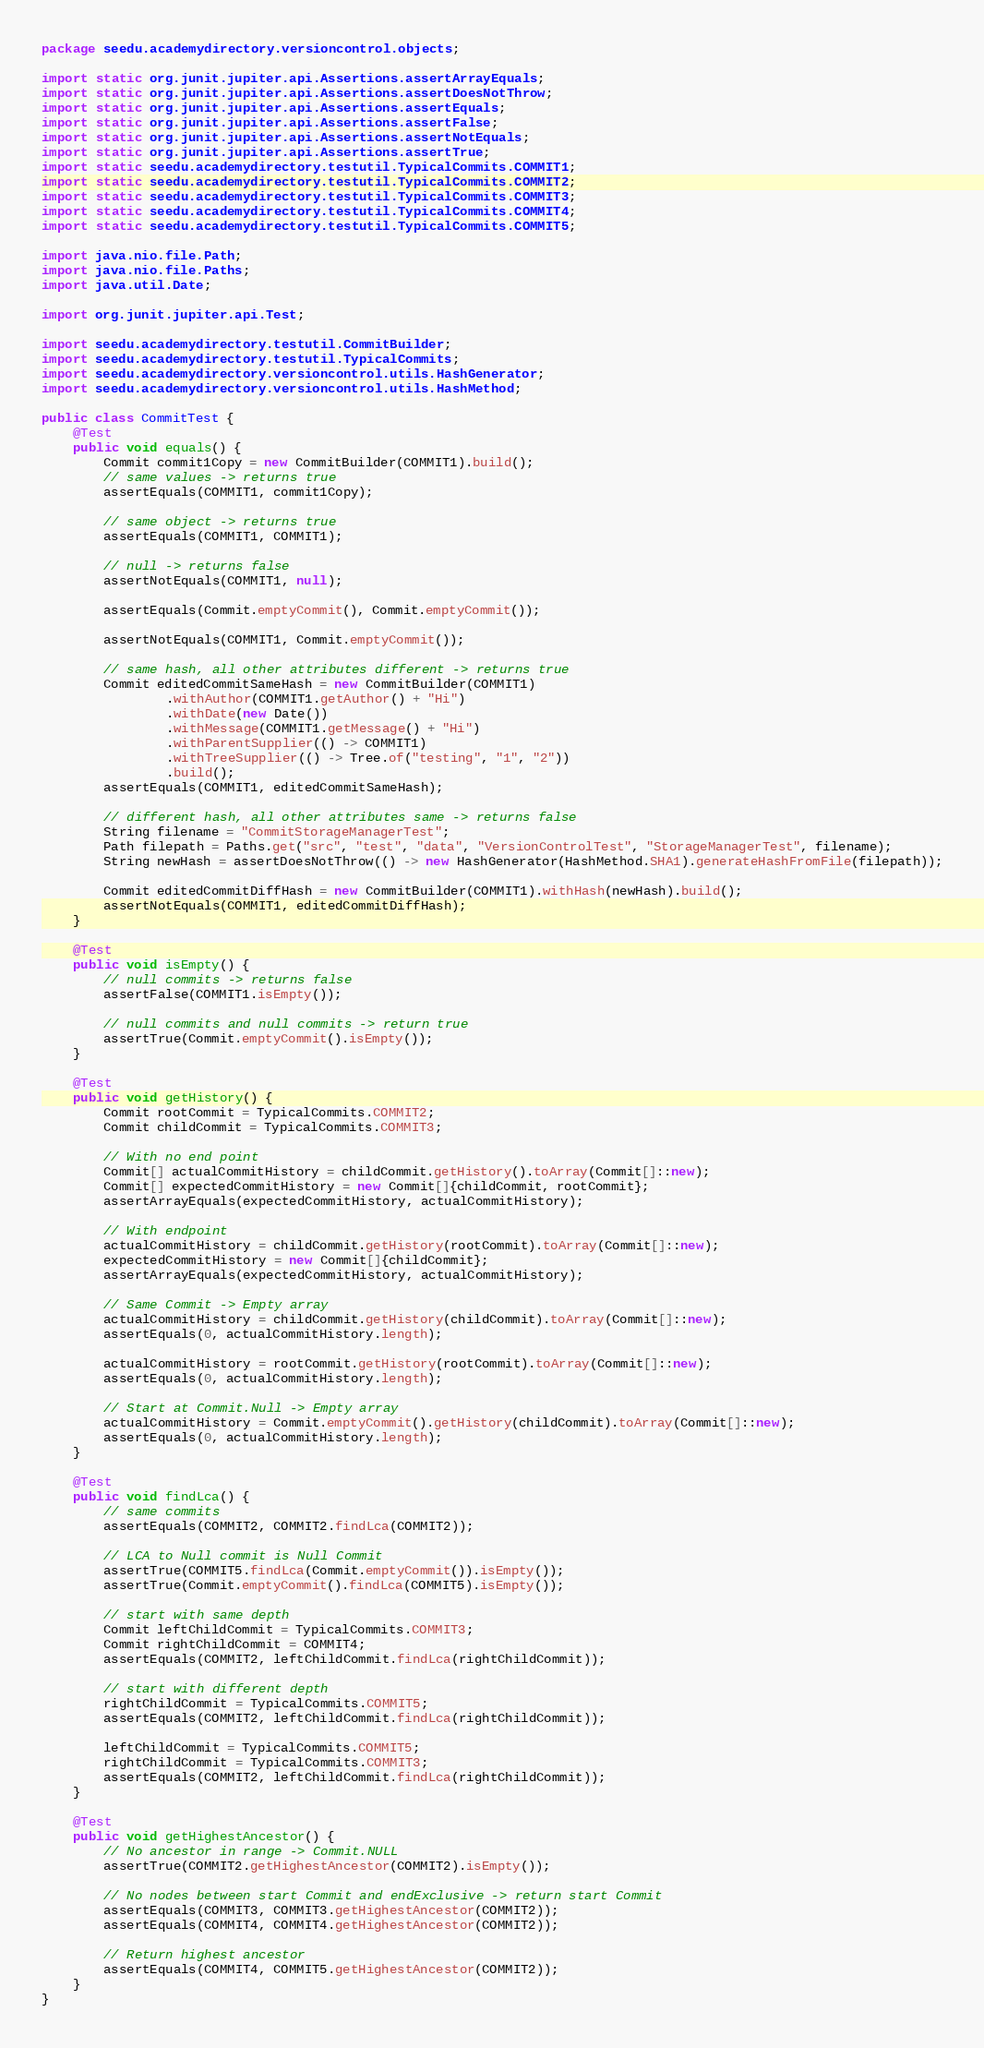<code> <loc_0><loc_0><loc_500><loc_500><_Java_>package seedu.academydirectory.versioncontrol.objects;

import static org.junit.jupiter.api.Assertions.assertArrayEquals;
import static org.junit.jupiter.api.Assertions.assertDoesNotThrow;
import static org.junit.jupiter.api.Assertions.assertEquals;
import static org.junit.jupiter.api.Assertions.assertFalse;
import static org.junit.jupiter.api.Assertions.assertNotEquals;
import static org.junit.jupiter.api.Assertions.assertTrue;
import static seedu.academydirectory.testutil.TypicalCommits.COMMIT1;
import static seedu.academydirectory.testutil.TypicalCommits.COMMIT2;
import static seedu.academydirectory.testutil.TypicalCommits.COMMIT3;
import static seedu.academydirectory.testutil.TypicalCommits.COMMIT4;
import static seedu.academydirectory.testutil.TypicalCommits.COMMIT5;

import java.nio.file.Path;
import java.nio.file.Paths;
import java.util.Date;

import org.junit.jupiter.api.Test;

import seedu.academydirectory.testutil.CommitBuilder;
import seedu.academydirectory.testutil.TypicalCommits;
import seedu.academydirectory.versioncontrol.utils.HashGenerator;
import seedu.academydirectory.versioncontrol.utils.HashMethod;

public class CommitTest {
    @Test
    public void equals() {
        Commit commit1Copy = new CommitBuilder(COMMIT1).build();
        // same values -> returns true
        assertEquals(COMMIT1, commit1Copy);

        // same object -> returns true
        assertEquals(COMMIT1, COMMIT1);

        // null -> returns false
        assertNotEquals(COMMIT1, null);

        assertEquals(Commit.emptyCommit(), Commit.emptyCommit());

        assertNotEquals(COMMIT1, Commit.emptyCommit());

        // same hash, all other attributes different -> returns true
        Commit editedCommitSameHash = new CommitBuilder(COMMIT1)
                .withAuthor(COMMIT1.getAuthor() + "Hi")
                .withDate(new Date())
                .withMessage(COMMIT1.getMessage() + "Hi")
                .withParentSupplier(() -> COMMIT1)
                .withTreeSupplier(() -> Tree.of("testing", "1", "2"))
                .build();
        assertEquals(COMMIT1, editedCommitSameHash);

        // different hash, all other attributes same -> returns false
        String filename = "CommitStorageManagerTest";
        Path filepath = Paths.get("src", "test", "data", "VersionControlTest", "StorageManagerTest", filename);
        String newHash = assertDoesNotThrow(() -> new HashGenerator(HashMethod.SHA1).generateHashFromFile(filepath));

        Commit editedCommitDiffHash = new CommitBuilder(COMMIT1).withHash(newHash).build();
        assertNotEquals(COMMIT1, editedCommitDiffHash);
    }

    @Test
    public void isEmpty() {
        // null commits -> returns false
        assertFalse(COMMIT1.isEmpty());

        // null commits and null commits -> return true
        assertTrue(Commit.emptyCommit().isEmpty());
    }

    @Test
    public void getHistory() {
        Commit rootCommit = TypicalCommits.COMMIT2;
        Commit childCommit = TypicalCommits.COMMIT3;

        // With no end point
        Commit[] actualCommitHistory = childCommit.getHistory().toArray(Commit[]::new);
        Commit[] expectedCommitHistory = new Commit[]{childCommit, rootCommit};
        assertArrayEquals(expectedCommitHistory, actualCommitHistory);

        // With endpoint
        actualCommitHistory = childCommit.getHistory(rootCommit).toArray(Commit[]::new);
        expectedCommitHistory = new Commit[]{childCommit};
        assertArrayEquals(expectedCommitHistory, actualCommitHistory);

        // Same Commit -> Empty array
        actualCommitHistory = childCommit.getHistory(childCommit).toArray(Commit[]::new);
        assertEquals(0, actualCommitHistory.length);

        actualCommitHistory = rootCommit.getHistory(rootCommit).toArray(Commit[]::new);
        assertEquals(0, actualCommitHistory.length);

        // Start at Commit.Null -> Empty array
        actualCommitHistory = Commit.emptyCommit().getHistory(childCommit).toArray(Commit[]::new);
        assertEquals(0, actualCommitHistory.length);
    }

    @Test
    public void findLca() {
        // same commits
        assertEquals(COMMIT2, COMMIT2.findLca(COMMIT2));

        // LCA to Null commit is Null Commit
        assertTrue(COMMIT5.findLca(Commit.emptyCommit()).isEmpty());
        assertTrue(Commit.emptyCommit().findLca(COMMIT5).isEmpty());

        // start with same depth
        Commit leftChildCommit = TypicalCommits.COMMIT3;
        Commit rightChildCommit = COMMIT4;
        assertEquals(COMMIT2, leftChildCommit.findLca(rightChildCommit));

        // start with different depth
        rightChildCommit = TypicalCommits.COMMIT5;
        assertEquals(COMMIT2, leftChildCommit.findLca(rightChildCommit));

        leftChildCommit = TypicalCommits.COMMIT5;
        rightChildCommit = TypicalCommits.COMMIT3;
        assertEquals(COMMIT2, leftChildCommit.findLca(rightChildCommit));
    }

    @Test
    public void getHighestAncestor() {
        // No ancestor in range -> Commit.NULL
        assertTrue(COMMIT2.getHighestAncestor(COMMIT2).isEmpty());

        // No nodes between start Commit and endExclusive -> return start Commit
        assertEquals(COMMIT3, COMMIT3.getHighestAncestor(COMMIT2));
        assertEquals(COMMIT4, COMMIT4.getHighestAncestor(COMMIT2));

        // Return highest ancestor
        assertEquals(COMMIT4, COMMIT5.getHighestAncestor(COMMIT2));
    }
}
</code> 